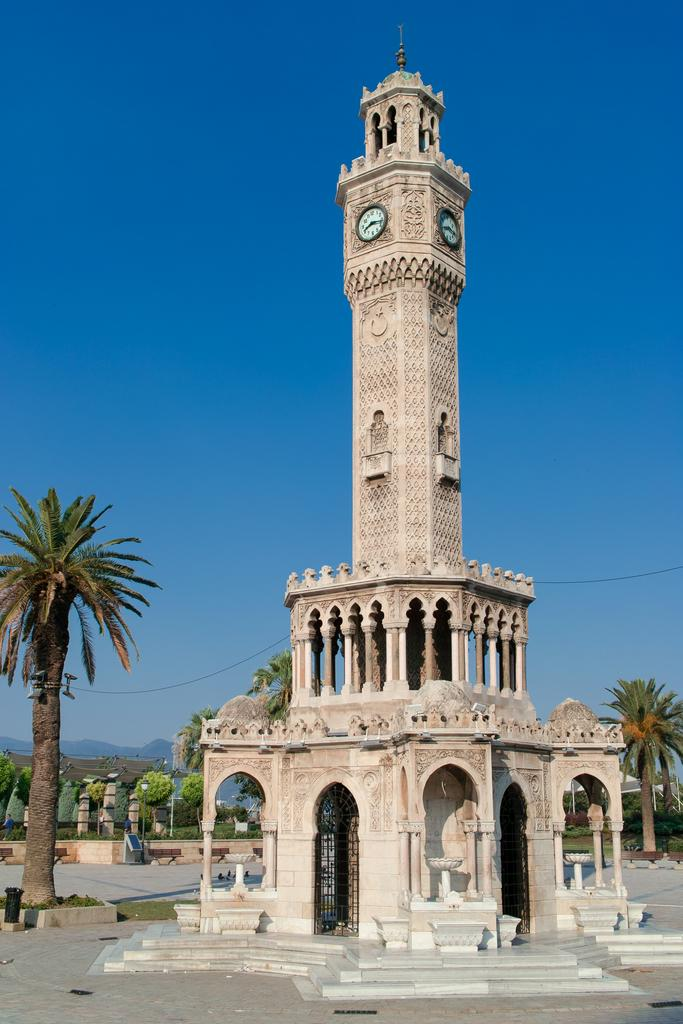What is the main structure in the image? There is a clock tower in the image. What type of vegetation can be seen in the image? There are trees visible in the image. What type of ground cover is present in the image? There is grass visible in the image. What type of berry is growing on the roof of the clock tower in the image? There is no berry growing on the roof of the clock tower in the image. 